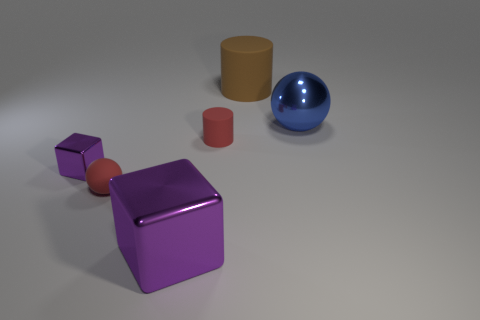Add 3 large gray metal cubes. How many objects exist? 9 Subtract all cylinders. How many objects are left? 4 Subtract 0 purple cylinders. How many objects are left? 6 Subtract all small brown cubes. Subtract all purple cubes. How many objects are left? 4 Add 4 big matte cylinders. How many big matte cylinders are left? 5 Add 1 small rubber cylinders. How many small rubber cylinders exist? 2 